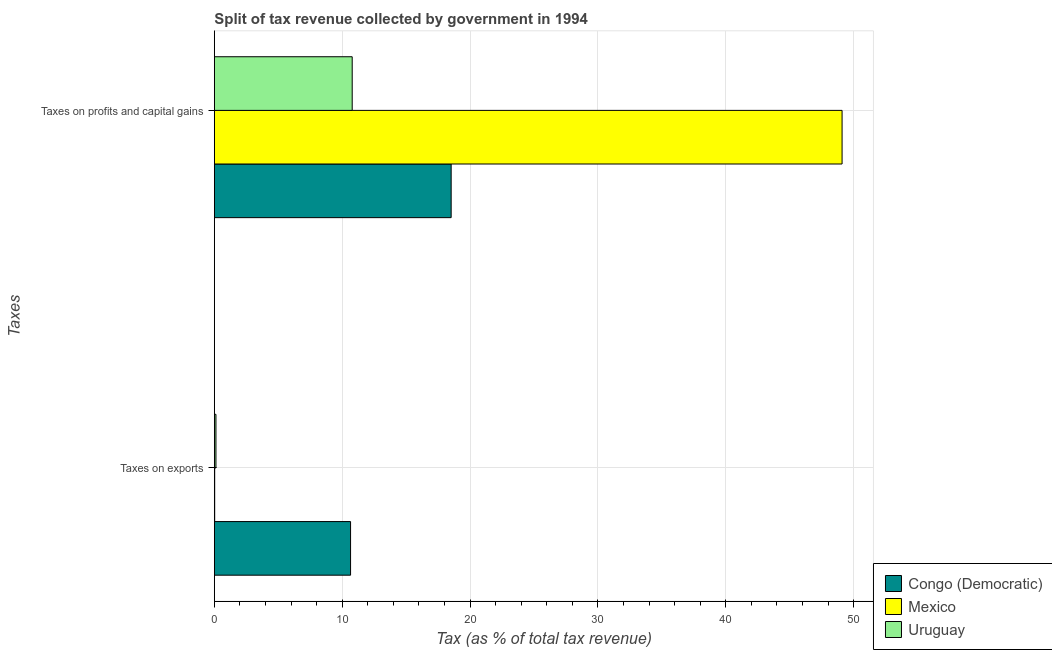How many bars are there on the 1st tick from the top?
Offer a terse response. 3. How many bars are there on the 2nd tick from the bottom?
Your response must be concise. 3. What is the label of the 1st group of bars from the top?
Keep it short and to the point. Taxes on profits and capital gains. What is the percentage of revenue obtained from taxes on profits and capital gains in Mexico?
Give a very brief answer. 49.1. Across all countries, what is the maximum percentage of revenue obtained from taxes on exports?
Provide a short and direct response. 10.65. Across all countries, what is the minimum percentage of revenue obtained from taxes on exports?
Ensure brevity in your answer.  0.03. In which country was the percentage of revenue obtained from taxes on exports minimum?
Provide a succinct answer. Mexico. What is the total percentage of revenue obtained from taxes on exports in the graph?
Keep it short and to the point. 10.81. What is the difference between the percentage of revenue obtained from taxes on profits and capital gains in Mexico and that in Congo (Democratic)?
Make the answer very short. 30.58. What is the difference between the percentage of revenue obtained from taxes on profits and capital gains in Congo (Democratic) and the percentage of revenue obtained from taxes on exports in Uruguay?
Offer a terse response. 18.4. What is the average percentage of revenue obtained from taxes on exports per country?
Provide a succinct answer. 3.6. What is the difference between the percentage of revenue obtained from taxes on profits and capital gains and percentage of revenue obtained from taxes on exports in Uruguay?
Make the answer very short. 10.66. What is the ratio of the percentage of revenue obtained from taxes on exports in Congo (Democratic) to that in Mexico?
Keep it short and to the point. 402.94. In how many countries, is the percentage of revenue obtained from taxes on exports greater than the average percentage of revenue obtained from taxes on exports taken over all countries?
Offer a terse response. 1. What does the 3rd bar from the top in Taxes on profits and capital gains represents?
Ensure brevity in your answer.  Congo (Democratic). What does the 3rd bar from the bottom in Taxes on exports represents?
Make the answer very short. Uruguay. What is the difference between two consecutive major ticks on the X-axis?
Offer a terse response. 10. What is the title of the graph?
Make the answer very short. Split of tax revenue collected by government in 1994. Does "Cambodia" appear as one of the legend labels in the graph?
Your answer should be very brief. No. What is the label or title of the X-axis?
Provide a short and direct response. Tax (as % of total tax revenue). What is the label or title of the Y-axis?
Ensure brevity in your answer.  Taxes. What is the Tax (as % of total tax revenue) in Congo (Democratic) in Taxes on exports?
Your response must be concise. 10.65. What is the Tax (as % of total tax revenue) in Mexico in Taxes on exports?
Keep it short and to the point. 0.03. What is the Tax (as % of total tax revenue) in Uruguay in Taxes on exports?
Provide a succinct answer. 0.13. What is the Tax (as % of total tax revenue) of Congo (Democratic) in Taxes on profits and capital gains?
Give a very brief answer. 18.52. What is the Tax (as % of total tax revenue) in Mexico in Taxes on profits and capital gains?
Provide a short and direct response. 49.1. What is the Tax (as % of total tax revenue) of Uruguay in Taxes on profits and capital gains?
Your answer should be compact. 10.78. Across all Taxes, what is the maximum Tax (as % of total tax revenue) of Congo (Democratic)?
Ensure brevity in your answer.  18.52. Across all Taxes, what is the maximum Tax (as % of total tax revenue) of Mexico?
Provide a succinct answer. 49.1. Across all Taxes, what is the maximum Tax (as % of total tax revenue) of Uruguay?
Make the answer very short. 10.78. Across all Taxes, what is the minimum Tax (as % of total tax revenue) in Congo (Democratic)?
Offer a very short reply. 10.65. Across all Taxes, what is the minimum Tax (as % of total tax revenue) of Mexico?
Give a very brief answer. 0.03. Across all Taxes, what is the minimum Tax (as % of total tax revenue) of Uruguay?
Your response must be concise. 0.13. What is the total Tax (as % of total tax revenue) of Congo (Democratic) in the graph?
Provide a succinct answer. 29.18. What is the total Tax (as % of total tax revenue) of Mexico in the graph?
Your answer should be compact. 49.12. What is the total Tax (as % of total tax revenue) of Uruguay in the graph?
Offer a terse response. 10.91. What is the difference between the Tax (as % of total tax revenue) in Congo (Democratic) in Taxes on exports and that in Taxes on profits and capital gains?
Offer a very short reply. -7.87. What is the difference between the Tax (as % of total tax revenue) of Mexico in Taxes on exports and that in Taxes on profits and capital gains?
Make the answer very short. -49.07. What is the difference between the Tax (as % of total tax revenue) in Uruguay in Taxes on exports and that in Taxes on profits and capital gains?
Your answer should be very brief. -10.66. What is the difference between the Tax (as % of total tax revenue) of Congo (Democratic) in Taxes on exports and the Tax (as % of total tax revenue) of Mexico in Taxes on profits and capital gains?
Your answer should be very brief. -38.44. What is the difference between the Tax (as % of total tax revenue) in Congo (Democratic) in Taxes on exports and the Tax (as % of total tax revenue) in Uruguay in Taxes on profits and capital gains?
Offer a very short reply. -0.13. What is the difference between the Tax (as % of total tax revenue) of Mexico in Taxes on exports and the Tax (as % of total tax revenue) of Uruguay in Taxes on profits and capital gains?
Give a very brief answer. -10.76. What is the average Tax (as % of total tax revenue) in Congo (Democratic) per Taxes?
Your answer should be very brief. 14.59. What is the average Tax (as % of total tax revenue) in Mexico per Taxes?
Ensure brevity in your answer.  24.56. What is the average Tax (as % of total tax revenue) in Uruguay per Taxes?
Keep it short and to the point. 5.45. What is the difference between the Tax (as % of total tax revenue) of Congo (Democratic) and Tax (as % of total tax revenue) of Mexico in Taxes on exports?
Your response must be concise. 10.63. What is the difference between the Tax (as % of total tax revenue) of Congo (Democratic) and Tax (as % of total tax revenue) of Uruguay in Taxes on exports?
Provide a short and direct response. 10.53. What is the difference between the Tax (as % of total tax revenue) in Mexico and Tax (as % of total tax revenue) in Uruguay in Taxes on exports?
Make the answer very short. -0.1. What is the difference between the Tax (as % of total tax revenue) of Congo (Democratic) and Tax (as % of total tax revenue) of Mexico in Taxes on profits and capital gains?
Give a very brief answer. -30.58. What is the difference between the Tax (as % of total tax revenue) of Congo (Democratic) and Tax (as % of total tax revenue) of Uruguay in Taxes on profits and capital gains?
Your answer should be compact. 7.74. What is the difference between the Tax (as % of total tax revenue) in Mexico and Tax (as % of total tax revenue) in Uruguay in Taxes on profits and capital gains?
Your answer should be compact. 38.32. What is the ratio of the Tax (as % of total tax revenue) in Congo (Democratic) in Taxes on exports to that in Taxes on profits and capital gains?
Keep it short and to the point. 0.58. What is the ratio of the Tax (as % of total tax revenue) in Mexico in Taxes on exports to that in Taxes on profits and capital gains?
Give a very brief answer. 0. What is the ratio of the Tax (as % of total tax revenue) in Uruguay in Taxes on exports to that in Taxes on profits and capital gains?
Your response must be concise. 0.01. What is the difference between the highest and the second highest Tax (as % of total tax revenue) in Congo (Democratic)?
Keep it short and to the point. 7.87. What is the difference between the highest and the second highest Tax (as % of total tax revenue) of Mexico?
Your answer should be very brief. 49.07. What is the difference between the highest and the second highest Tax (as % of total tax revenue) in Uruguay?
Make the answer very short. 10.66. What is the difference between the highest and the lowest Tax (as % of total tax revenue) in Congo (Democratic)?
Your answer should be compact. 7.87. What is the difference between the highest and the lowest Tax (as % of total tax revenue) in Mexico?
Make the answer very short. 49.07. What is the difference between the highest and the lowest Tax (as % of total tax revenue) in Uruguay?
Your answer should be very brief. 10.66. 